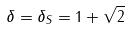Convert formula to latex. <formula><loc_0><loc_0><loc_500><loc_500>\delta = \delta _ { S } = 1 + \sqrt { 2 }</formula> 